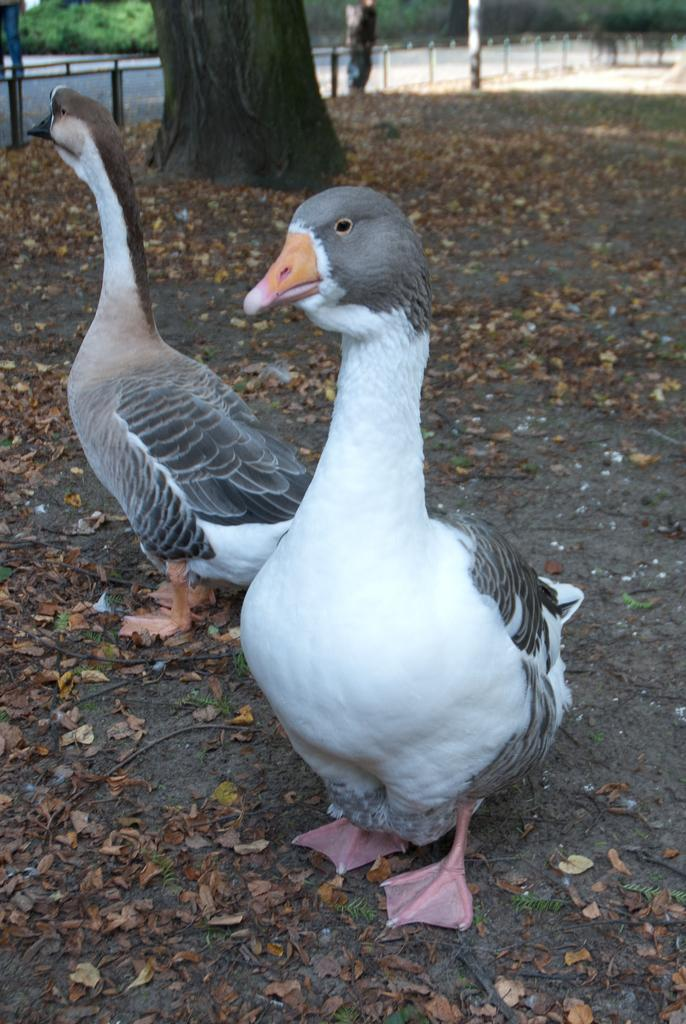What type of animals can be seen on the ground in the image? There are birds on the ground in the image. What else can be seen on the ground in the image? Dried leaves are visible in the image. What type of barrier is present in the image? There is a fence in the image. What can be seen in the background of the image? Trees are present in the background of the image. What type of seed is the bird about to plant on the desk in the image? There is no desk present in the image, and the birds are not shown planting any seeds. 